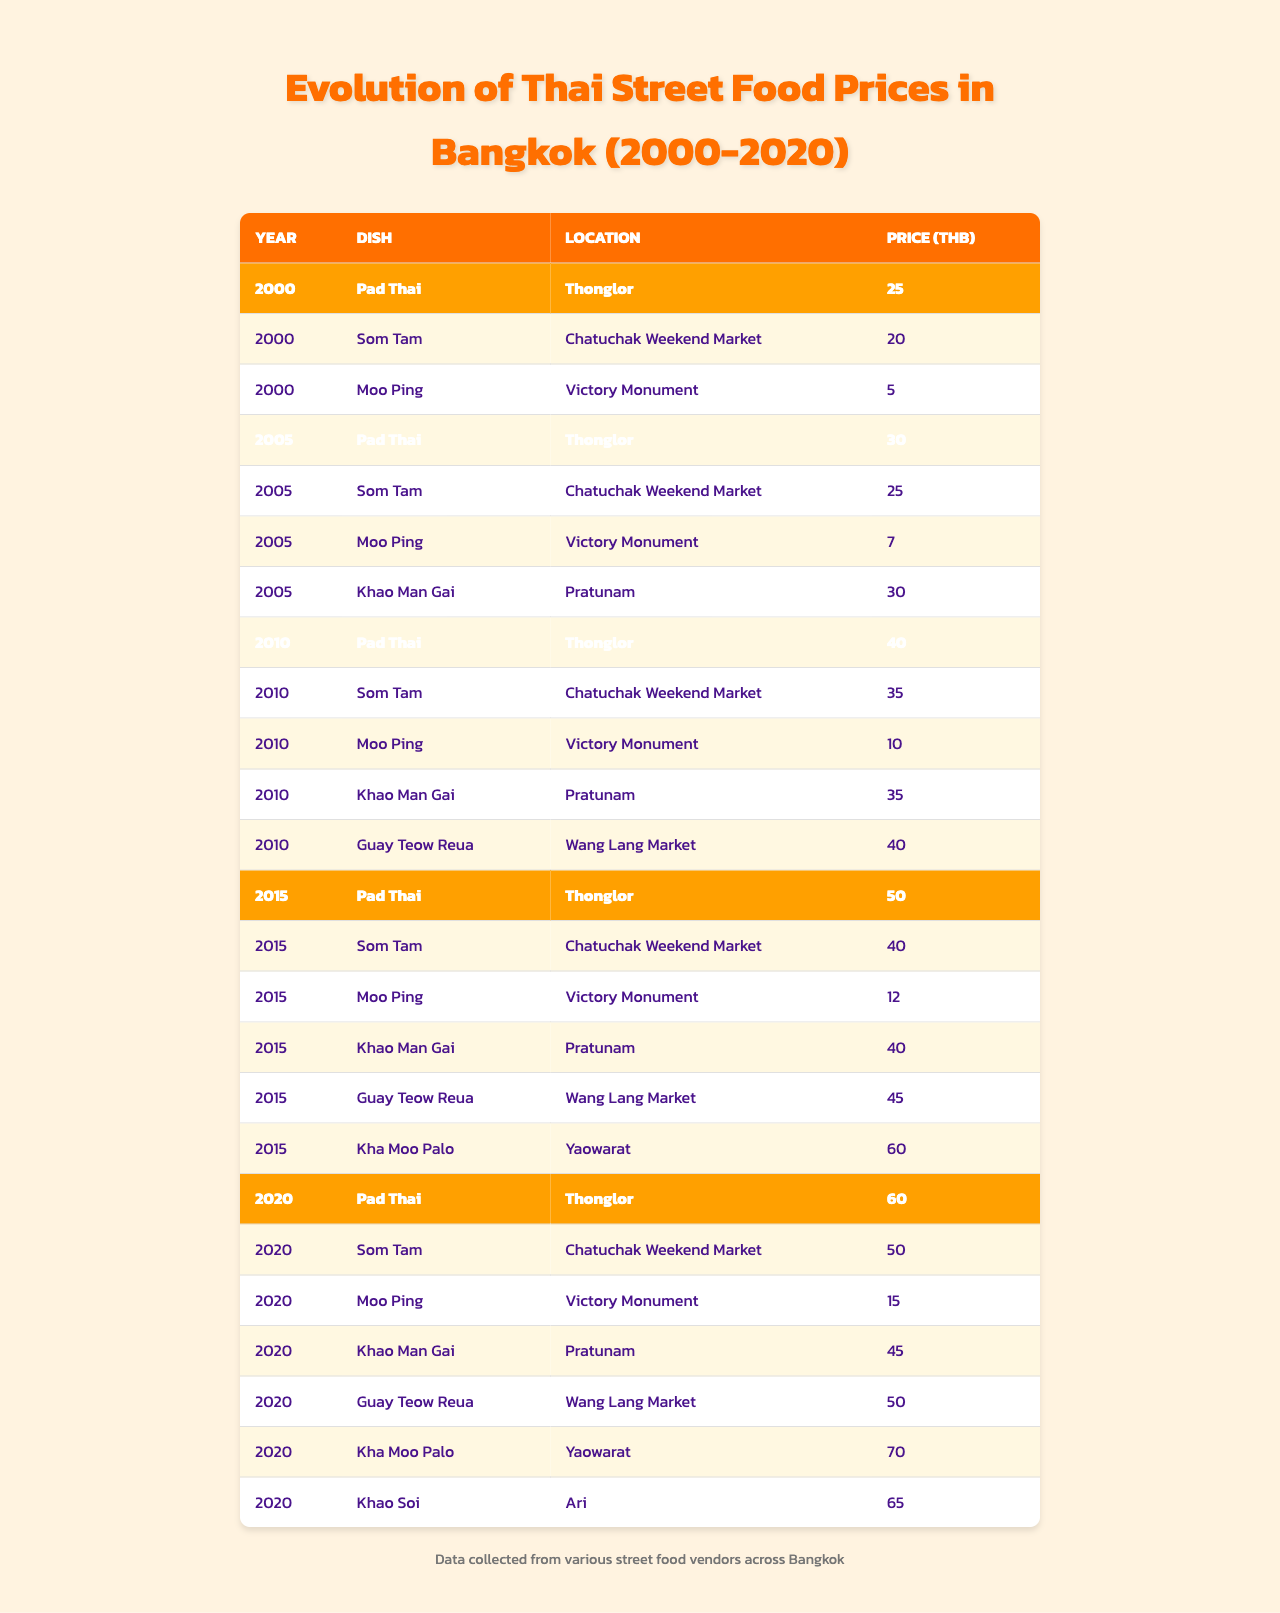What was the price of Pad Thai in 2010? The table shows that in 2010, the price of Pad Thai was listed as 40 THB under the "Price (THB)" column for that year.
Answer: 40 THB Which dish had the lowest price in 2000? In 2000, the dish with the lowest price was Moo Ping, which cost 5 THB according to the table data for that year.
Answer: Moo Ping How much did the price of Som Tam increase from 2005 to 2020? The price of Som Tam was 25 THB in 2005 and increased to 50 THB in 2020. Therefore, the increase is 50 - 25 = 25 THB.
Answer: 25 THB Which dish saw the largest price increase from 2000 to 2020? To find the largest increase, we look at the prices for each dish in 2000 and 2020: Pad Thai increased by 35 THB, Som Tam by 30 THB, Moo Ping by 10 THB, Khao Man Gai by 15 THB, Guay Teow Reua by 10 THB, and Kha Moo Palo by 10 THB. The largest increase was for Pad Thai.
Answer: Pad Thai What was the average price of Moo Ping from 2000 to 2020? The prices of Moo Ping across the years are 5 THB (2000), 7 THB (2005), 10 THB (2010), 12 THB (2015), and 15 THB (2020). Adding these gives 5 + 7 + 10 + 12 + 15 = 49 THB, and dividing by 5 data points gives 49/5 = 9.8 THB.
Answer: 9.8 THB True or false: The price of Khao Man Gai decreased from 2010 to 2015. In 2010, the price of Khao Man Gai was 35 THB, and it increased to 40 THB in 2015. Thus, the price did not decrease, so the statement is false.
Answer: False Which location offered the most expensive Pad Thai in 2020? The table indicates that in 2020, Pad Thai in Thonglor cost 60 THB, and this was the only account for Pad Thai in 2020, making it the most expensive option available for that dish.
Answer: Thonglor In how many years did Khao Soi appear in the data? Khao Soi is only listed for the year 2020, indicating it appeared in the data for just one year.
Answer: 1 year 